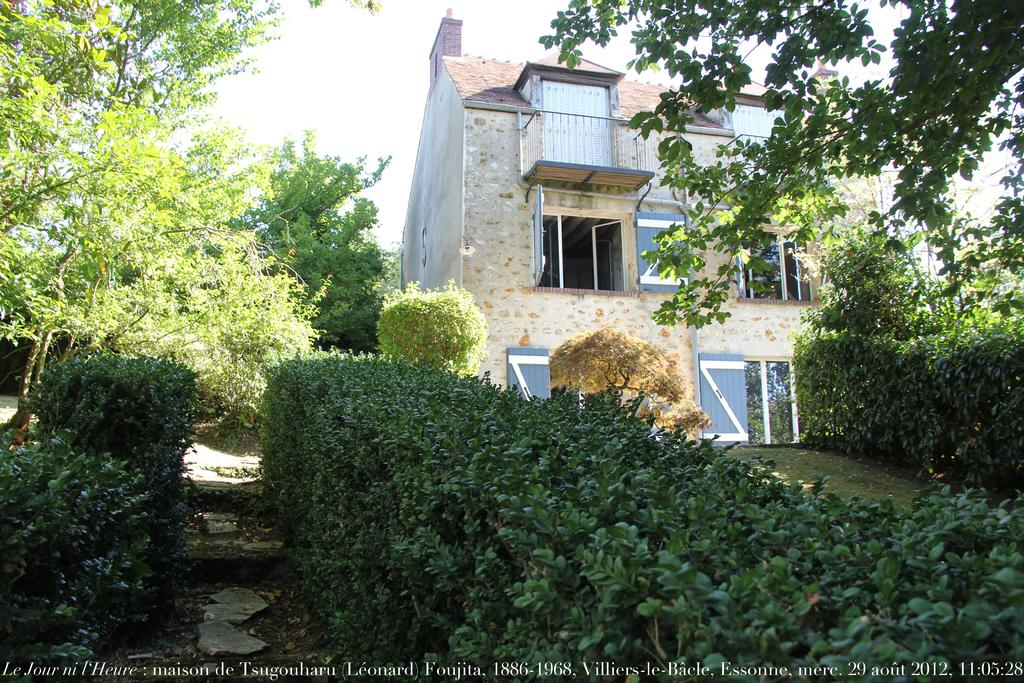What can be seen in the foreground of the image? In the foreground of the image, there are plants, a path to walk, and trees. What is visible in the background of the image? In the background of the image, there are trees, a building, and the sky. Can you describe the path in the foreground? The path in the foreground is visible and appears to be a place where someone could walk. What type of structure is in the background of the image? There is a building in the background of the image. How many blades are attached to the balloon in the image? There is no balloon or blade present in the image. What type of planes can be seen flying in the image? There are no planes visible in the image; the image features plants, a path, trees, and a building in the background. 